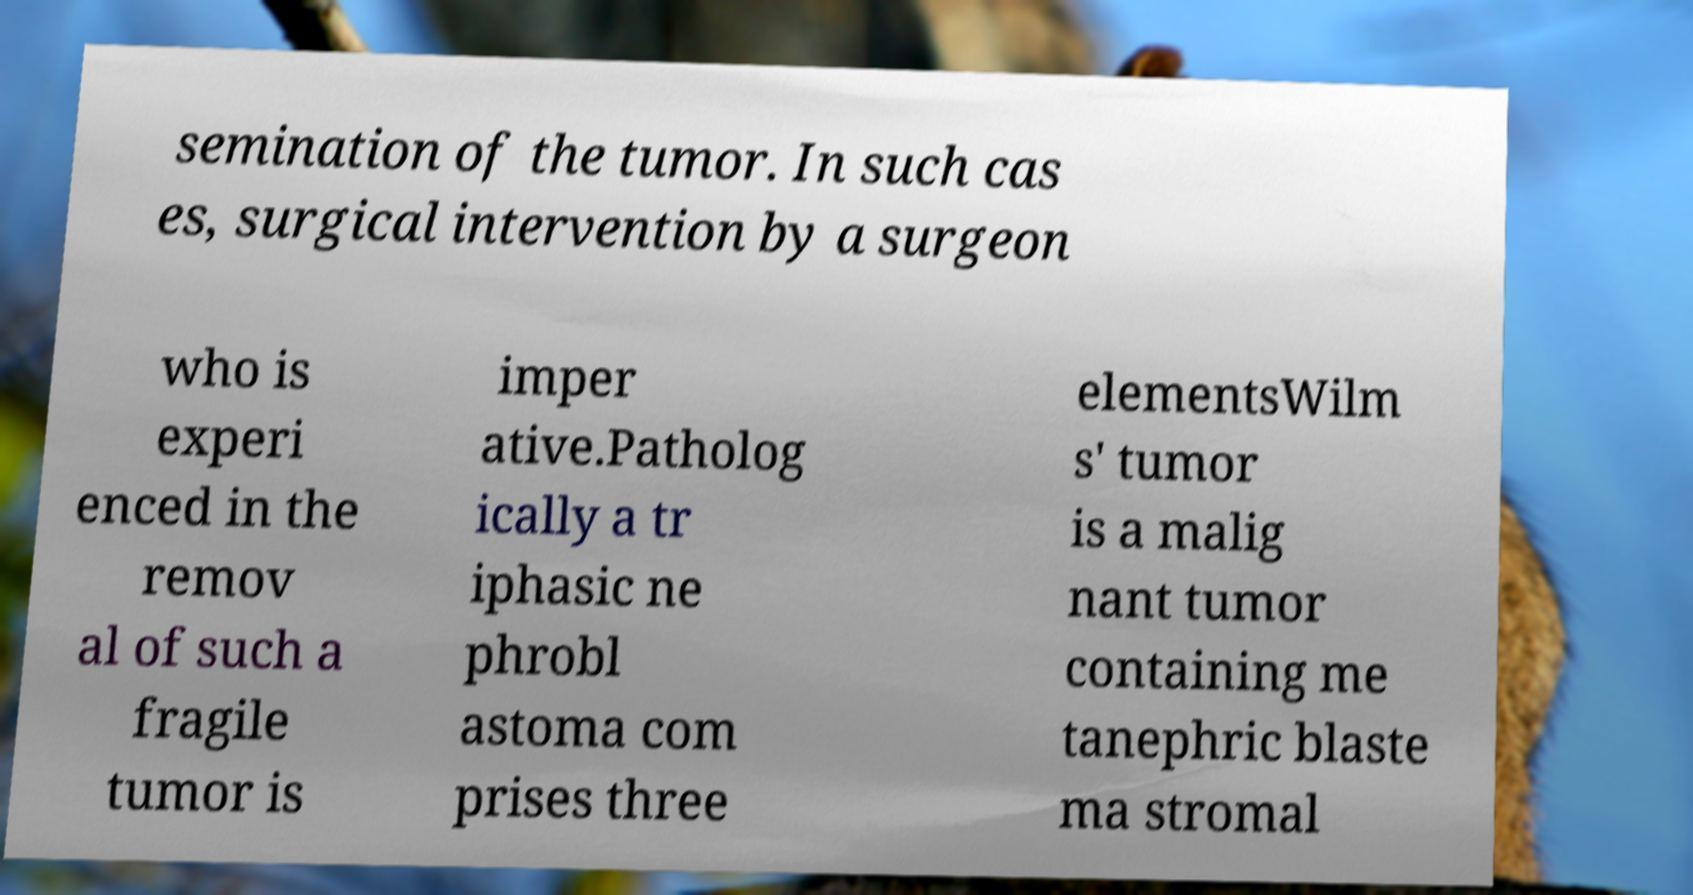Please read and relay the text visible in this image. What does it say? semination of the tumor. In such cas es, surgical intervention by a surgeon who is experi enced in the remov al of such a fragile tumor is imper ative.Patholog ically a tr iphasic ne phrobl astoma com prises three elementsWilm s' tumor is a malig nant tumor containing me tanephric blaste ma stromal 